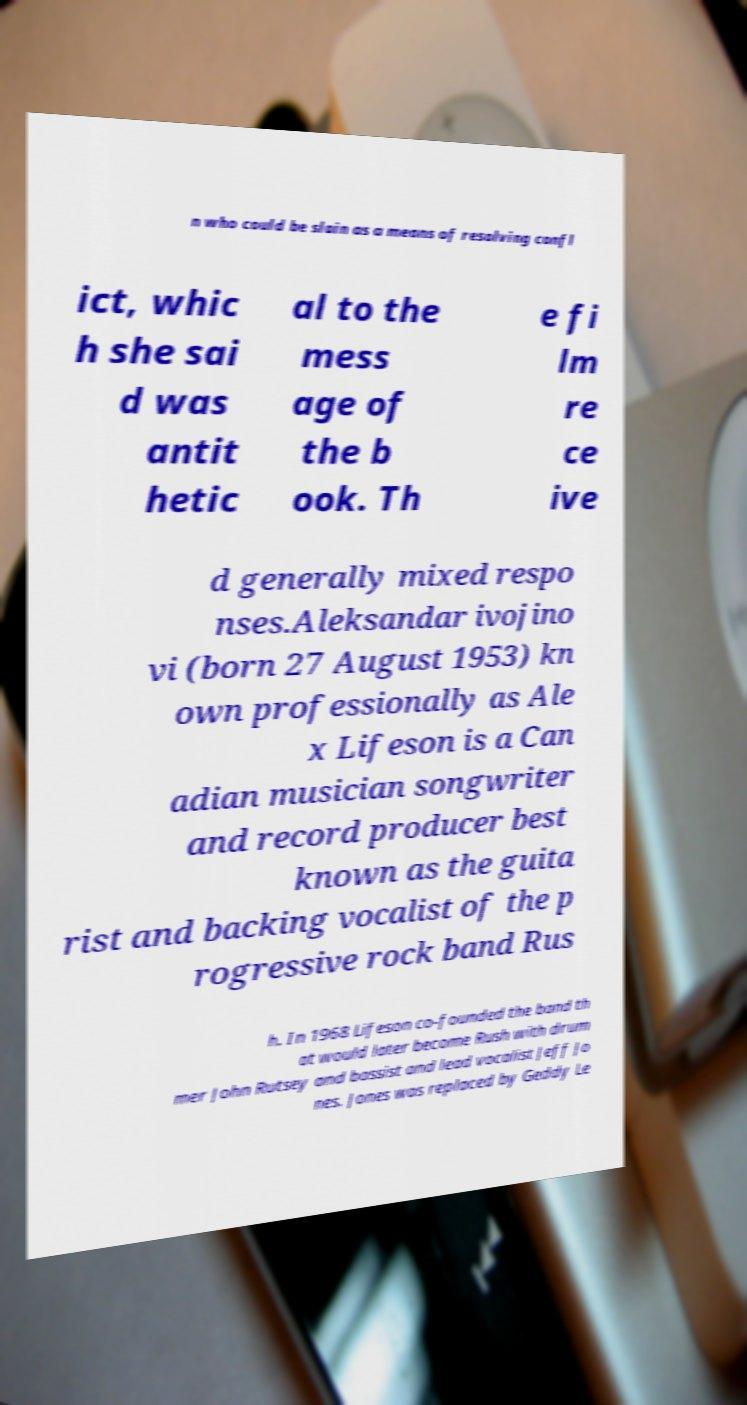For documentation purposes, I need the text within this image transcribed. Could you provide that? n who could be slain as a means of resolving confl ict, whic h she sai d was antit hetic al to the mess age of the b ook. Th e fi lm re ce ive d generally mixed respo nses.Aleksandar ivojino vi (born 27 August 1953) kn own professionally as Ale x Lifeson is a Can adian musician songwriter and record producer best known as the guita rist and backing vocalist of the p rogressive rock band Rus h. In 1968 Lifeson co-founded the band th at would later become Rush with drum mer John Rutsey and bassist and lead vocalist Jeff Jo nes. Jones was replaced by Geddy Le 